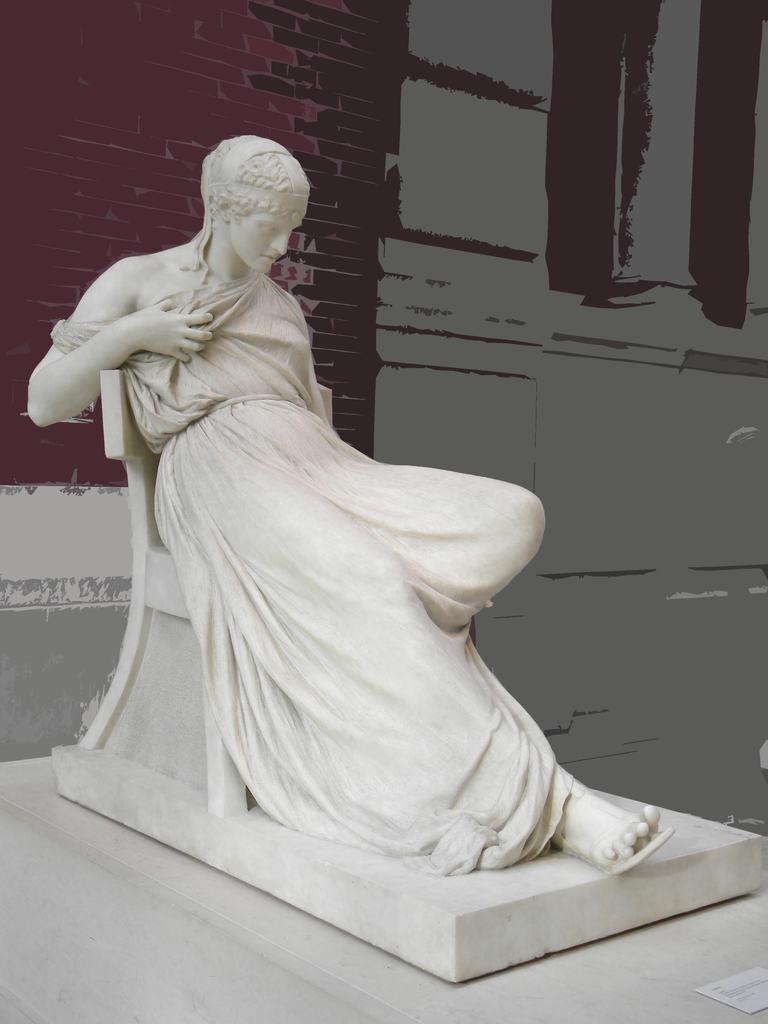Can you describe this image briefly? In this image we can see a sculpture. Behind the sculpture, we can see a wall. In the bottom right we can see a paper with text. 